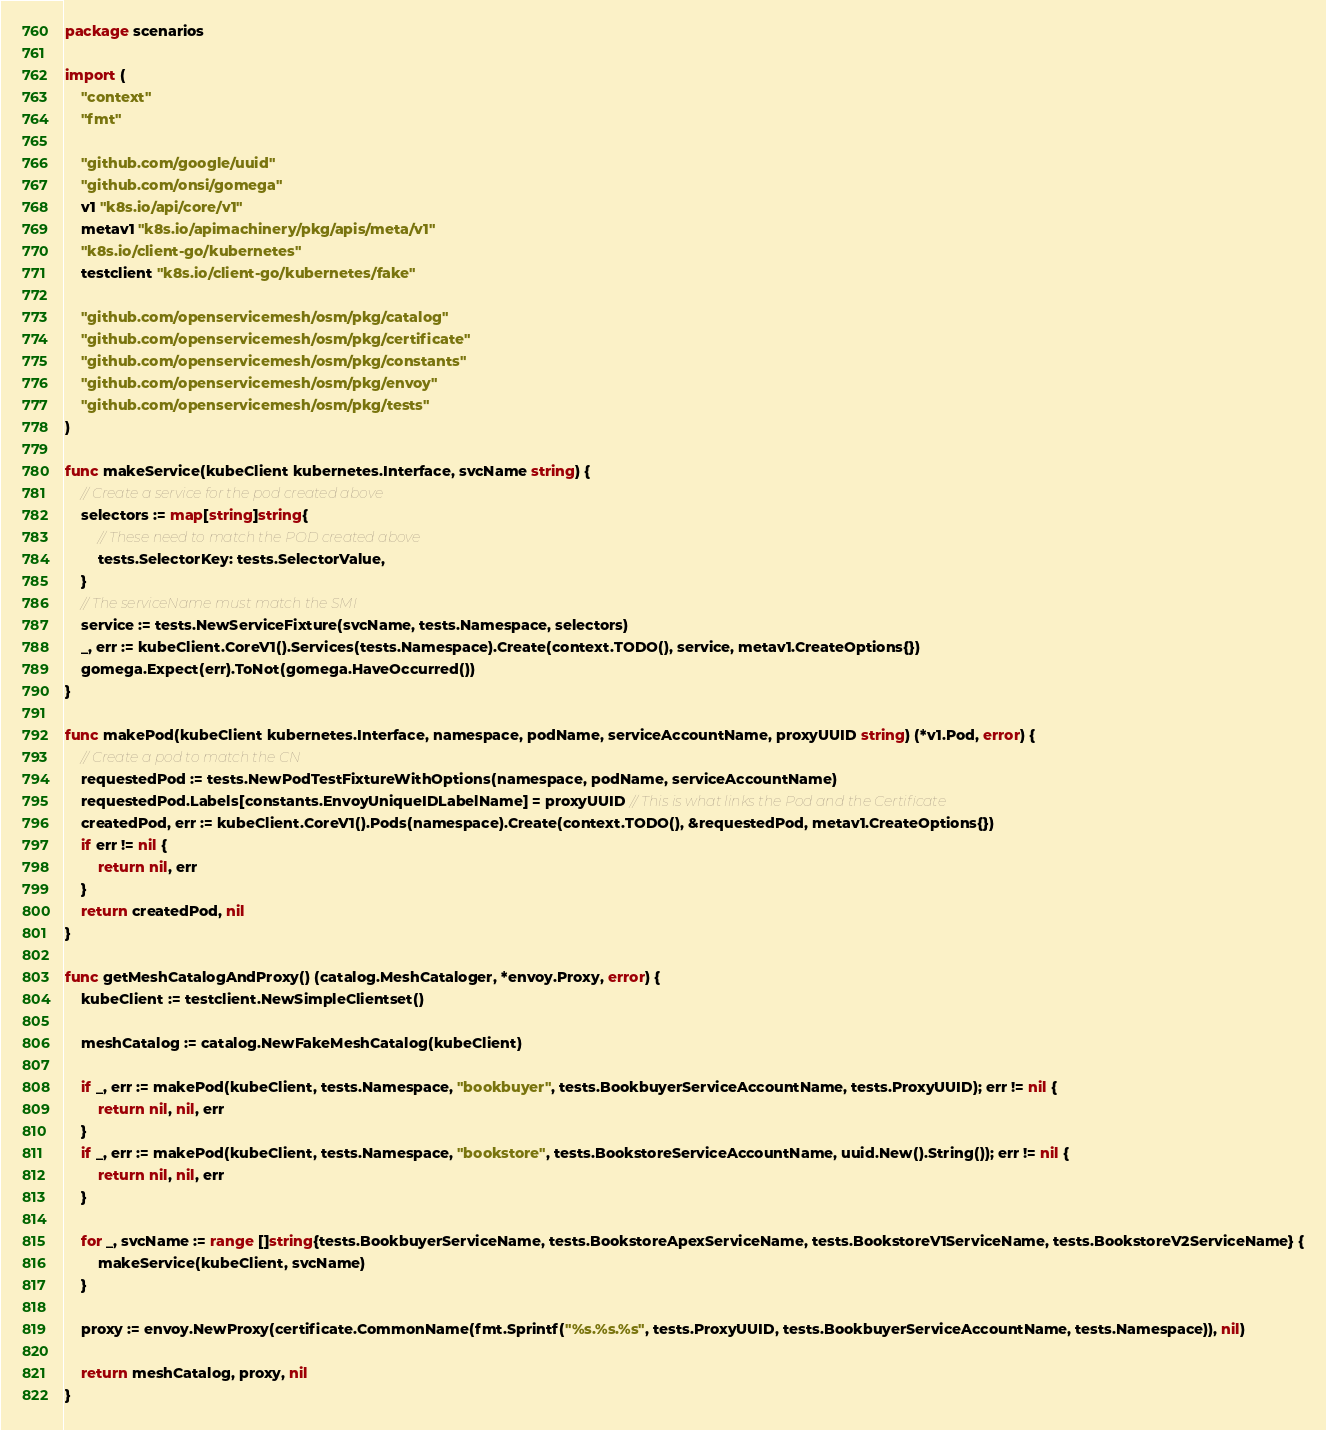<code> <loc_0><loc_0><loc_500><loc_500><_Go_>package scenarios

import (
	"context"
	"fmt"

	"github.com/google/uuid"
	"github.com/onsi/gomega"
	v1 "k8s.io/api/core/v1"
	metav1 "k8s.io/apimachinery/pkg/apis/meta/v1"
	"k8s.io/client-go/kubernetes"
	testclient "k8s.io/client-go/kubernetes/fake"

	"github.com/openservicemesh/osm/pkg/catalog"
	"github.com/openservicemesh/osm/pkg/certificate"
	"github.com/openservicemesh/osm/pkg/constants"
	"github.com/openservicemesh/osm/pkg/envoy"
	"github.com/openservicemesh/osm/pkg/tests"
)

func makeService(kubeClient kubernetes.Interface, svcName string) {
	// Create a service for the pod created above
	selectors := map[string]string{
		// These need to match the POD created above
		tests.SelectorKey: tests.SelectorValue,
	}
	// The serviceName must match the SMI
	service := tests.NewServiceFixture(svcName, tests.Namespace, selectors)
	_, err := kubeClient.CoreV1().Services(tests.Namespace).Create(context.TODO(), service, metav1.CreateOptions{})
	gomega.Expect(err).ToNot(gomega.HaveOccurred())
}

func makePod(kubeClient kubernetes.Interface, namespace, podName, serviceAccountName, proxyUUID string) (*v1.Pod, error) {
	// Create a pod to match the CN
	requestedPod := tests.NewPodTestFixtureWithOptions(namespace, podName, serviceAccountName)
	requestedPod.Labels[constants.EnvoyUniqueIDLabelName] = proxyUUID // This is what links the Pod and the Certificate
	createdPod, err := kubeClient.CoreV1().Pods(namespace).Create(context.TODO(), &requestedPod, metav1.CreateOptions{})
	if err != nil {
		return nil, err
	}
	return createdPod, nil
}

func getMeshCatalogAndProxy() (catalog.MeshCataloger, *envoy.Proxy, error) {
	kubeClient := testclient.NewSimpleClientset()

	meshCatalog := catalog.NewFakeMeshCatalog(kubeClient)

	if _, err := makePod(kubeClient, tests.Namespace, "bookbuyer", tests.BookbuyerServiceAccountName, tests.ProxyUUID); err != nil {
		return nil, nil, err
	}
	if _, err := makePod(kubeClient, tests.Namespace, "bookstore", tests.BookstoreServiceAccountName, uuid.New().String()); err != nil {
		return nil, nil, err
	}

	for _, svcName := range []string{tests.BookbuyerServiceName, tests.BookstoreApexServiceName, tests.BookstoreV1ServiceName, tests.BookstoreV2ServiceName} {
		makeService(kubeClient, svcName)
	}

	proxy := envoy.NewProxy(certificate.CommonName(fmt.Sprintf("%s.%s.%s", tests.ProxyUUID, tests.BookbuyerServiceAccountName, tests.Namespace)), nil)

	return meshCatalog, proxy, nil
}
</code> 